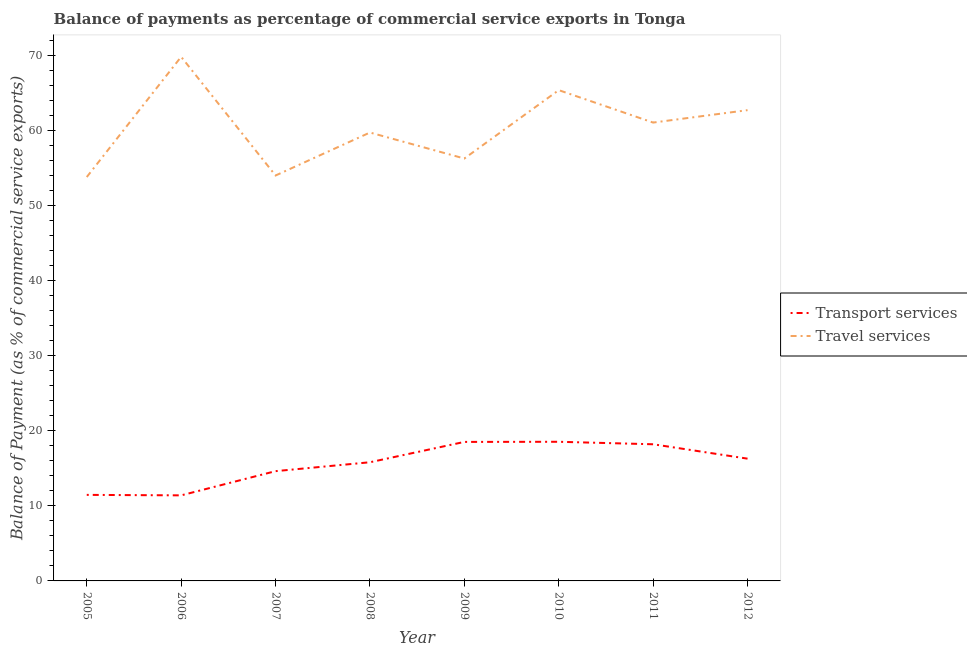Does the line corresponding to balance of payments of transport services intersect with the line corresponding to balance of payments of travel services?
Ensure brevity in your answer.  No. What is the balance of payments of transport services in 2010?
Offer a terse response. 18.55. Across all years, what is the maximum balance of payments of transport services?
Your response must be concise. 18.55. Across all years, what is the minimum balance of payments of transport services?
Keep it short and to the point. 11.41. In which year was the balance of payments of transport services maximum?
Provide a succinct answer. 2010. In which year was the balance of payments of transport services minimum?
Ensure brevity in your answer.  2006. What is the total balance of payments of transport services in the graph?
Offer a terse response. 124.96. What is the difference between the balance of payments of transport services in 2011 and that in 2012?
Provide a succinct answer. 1.92. What is the difference between the balance of payments of travel services in 2007 and the balance of payments of transport services in 2009?
Provide a short and direct response. 35.52. What is the average balance of payments of travel services per year?
Your answer should be very brief. 60.41. In the year 2010, what is the difference between the balance of payments of travel services and balance of payments of transport services?
Your answer should be compact. 46.89. What is the ratio of the balance of payments of transport services in 2006 to that in 2012?
Your response must be concise. 0.7. What is the difference between the highest and the second highest balance of payments of travel services?
Your answer should be compact. 4.45. What is the difference between the highest and the lowest balance of payments of transport services?
Your answer should be very brief. 7.15. In how many years, is the balance of payments of transport services greater than the average balance of payments of transport services taken over all years?
Ensure brevity in your answer.  5. Is the sum of the balance of payments of travel services in 2007 and 2011 greater than the maximum balance of payments of transport services across all years?
Provide a short and direct response. Yes. Is the balance of payments of travel services strictly greater than the balance of payments of transport services over the years?
Ensure brevity in your answer.  Yes. How many lines are there?
Keep it short and to the point. 2. Does the graph contain any zero values?
Offer a very short reply. No. Where does the legend appear in the graph?
Give a very brief answer. Center right. What is the title of the graph?
Offer a very short reply. Balance of payments as percentage of commercial service exports in Tonga. What is the label or title of the Y-axis?
Provide a short and direct response. Balance of Payment (as % of commercial service exports). What is the Balance of Payment (as % of commercial service exports) of Transport services in 2005?
Ensure brevity in your answer.  11.47. What is the Balance of Payment (as % of commercial service exports) of Travel services in 2005?
Your response must be concise. 53.86. What is the Balance of Payment (as % of commercial service exports) in Transport services in 2006?
Provide a short and direct response. 11.41. What is the Balance of Payment (as % of commercial service exports) in Travel services in 2006?
Ensure brevity in your answer.  69.89. What is the Balance of Payment (as % of commercial service exports) of Transport services in 2007?
Provide a succinct answer. 14.64. What is the Balance of Payment (as % of commercial service exports) of Travel services in 2007?
Keep it short and to the point. 54.06. What is the Balance of Payment (as % of commercial service exports) of Transport services in 2008?
Your response must be concise. 15.82. What is the Balance of Payment (as % of commercial service exports) of Travel services in 2008?
Provide a succinct answer. 59.79. What is the Balance of Payment (as % of commercial service exports) of Transport services in 2009?
Offer a terse response. 18.54. What is the Balance of Payment (as % of commercial service exports) in Travel services in 2009?
Offer a very short reply. 56.33. What is the Balance of Payment (as % of commercial service exports) of Transport services in 2010?
Offer a very short reply. 18.55. What is the Balance of Payment (as % of commercial service exports) in Travel services in 2010?
Provide a short and direct response. 65.44. What is the Balance of Payment (as % of commercial service exports) in Transport services in 2011?
Keep it short and to the point. 18.22. What is the Balance of Payment (as % of commercial service exports) of Travel services in 2011?
Offer a terse response. 61.12. What is the Balance of Payment (as % of commercial service exports) of Transport services in 2012?
Your answer should be compact. 16.3. What is the Balance of Payment (as % of commercial service exports) in Travel services in 2012?
Provide a short and direct response. 62.78. Across all years, what is the maximum Balance of Payment (as % of commercial service exports) in Transport services?
Your answer should be compact. 18.55. Across all years, what is the maximum Balance of Payment (as % of commercial service exports) of Travel services?
Keep it short and to the point. 69.89. Across all years, what is the minimum Balance of Payment (as % of commercial service exports) in Transport services?
Your answer should be very brief. 11.41. Across all years, what is the minimum Balance of Payment (as % of commercial service exports) of Travel services?
Provide a succinct answer. 53.86. What is the total Balance of Payment (as % of commercial service exports) in Transport services in the graph?
Your answer should be compact. 124.96. What is the total Balance of Payment (as % of commercial service exports) in Travel services in the graph?
Your answer should be very brief. 483.26. What is the difference between the Balance of Payment (as % of commercial service exports) of Transport services in 2005 and that in 2006?
Provide a succinct answer. 0.06. What is the difference between the Balance of Payment (as % of commercial service exports) in Travel services in 2005 and that in 2006?
Provide a succinct answer. -16.03. What is the difference between the Balance of Payment (as % of commercial service exports) of Transport services in 2005 and that in 2007?
Give a very brief answer. -3.16. What is the difference between the Balance of Payment (as % of commercial service exports) in Travel services in 2005 and that in 2007?
Provide a succinct answer. -0.2. What is the difference between the Balance of Payment (as % of commercial service exports) of Transport services in 2005 and that in 2008?
Offer a terse response. -4.35. What is the difference between the Balance of Payment (as % of commercial service exports) in Travel services in 2005 and that in 2008?
Provide a succinct answer. -5.94. What is the difference between the Balance of Payment (as % of commercial service exports) in Transport services in 2005 and that in 2009?
Offer a terse response. -7.06. What is the difference between the Balance of Payment (as % of commercial service exports) in Travel services in 2005 and that in 2009?
Keep it short and to the point. -2.47. What is the difference between the Balance of Payment (as % of commercial service exports) in Transport services in 2005 and that in 2010?
Ensure brevity in your answer.  -7.08. What is the difference between the Balance of Payment (as % of commercial service exports) in Travel services in 2005 and that in 2010?
Your response must be concise. -11.59. What is the difference between the Balance of Payment (as % of commercial service exports) of Transport services in 2005 and that in 2011?
Ensure brevity in your answer.  -6.75. What is the difference between the Balance of Payment (as % of commercial service exports) of Travel services in 2005 and that in 2011?
Provide a succinct answer. -7.26. What is the difference between the Balance of Payment (as % of commercial service exports) of Transport services in 2005 and that in 2012?
Offer a terse response. -4.83. What is the difference between the Balance of Payment (as % of commercial service exports) in Travel services in 2005 and that in 2012?
Offer a very short reply. -8.92. What is the difference between the Balance of Payment (as % of commercial service exports) of Transport services in 2006 and that in 2007?
Your response must be concise. -3.23. What is the difference between the Balance of Payment (as % of commercial service exports) of Travel services in 2006 and that in 2007?
Your answer should be very brief. 15.83. What is the difference between the Balance of Payment (as % of commercial service exports) in Transport services in 2006 and that in 2008?
Your response must be concise. -4.42. What is the difference between the Balance of Payment (as % of commercial service exports) of Travel services in 2006 and that in 2008?
Your answer should be very brief. 10.1. What is the difference between the Balance of Payment (as % of commercial service exports) in Transport services in 2006 and that in 2009?
Provide a succinct answer. -7.13. What is the difference between the Balance of Payment (as % of commercial service exports) in Travel services in 2006 and that in 2009?
Offer a very short reply. 13.56. What is the difference between the Balance of Payment (as % of commercial service exports) of Transport services in 2006 and that in 2010?
Offer a terse response. -7.15. What is the difference between the Balance of Payment (as % of commercial service exports) in Travel services in 2006 and that in 2010?
Ensure brevity in your answer.  4.45. What is the difference between the Balance of Payment (as % of commercial service exports) of Transport services in 2006 and that in 2011?
Offer a very short reply. -6.81. What is the difference between the Balance of Payment (as % of commercial service exports) in Travel services in 2006 and that in 2011?
Your answer should be compact. 8.77. What is the difference between the Balance of Payment (as % of commercial service exports) in Transport services in 2006 and that in 2012?
Offer a very short reply. -4.89. What is the difference between the Balance of Payment (as % of commercial service exports) of Travel services in 2006 and that in 2012?
Make the answer very short. 7.11. What is the difference between the Balance of Payment (as % of commercial service exports) of Transport services in 2007 and that in 2008?
Give a very brief answer. -1.19. What is the difference between the Balance of Payment (as % of commercial service exports) of Travel services in 2007 and that in 2008?
Make the answer very short. -5.73. What is the difference between the Balance of Payment (as % of commercial service exports) of Transport services in 2007 and that in 2009?
Make the answer very short. -3.9. What is the difference between the Balance of Payment (as % of commercial service exports) in Travel services in 2007 and that in 2009?
Give a very brief answer. -2.27. What is the difference between the Balance of Payment (as % of commercial service exports) of Transport services in 2007 and that in 2010?
Make the answer very short. -3.92. What is the difference between the Balance of Payment (as % of commercial service exports) of Travel services in 2007 and that in 2010?
Provide a succinct answer. -11.38. What is the difference between the Balance of Payment (as % of commercial service exports) in Transport services in 2007 and that in 2011?
Your answer should be compact. -3.58. What is the difference between the Balance of Payment (as % of commercial service exports) in Travel services in 2007 and that in 2011?
Ensure brevity in your answer.  -7.06. What is the difference between the Balance of Payment (as % of commercial service exports) of Transport services in 2007 and that in 2012?
Offer a terse response. -1.67. What is the difference between the Balance of Payment (as % of commercial service exports) of Travel services in 2007 and that in 2012?
Provide a short and direct response. -8.72. What is the difference between the Balance of Payment (as % of commercial service exports) of Transport services in 2008 and that in 2009?
Your answer should be compact. -2.71. What is the difference between the Balance of Payment (as % of commercial service exports) of Travel services in 2008 and that in 2009?
Offer a very short reply. 3.47. What is the difference between the Balance of Payment (as % of commercial service exports) of Transport services in 2008 and that in 2010?
Give a very brief answer. -2.73. What is the difference between the Balance of Payment (as % of commercial service exports) in Travel services in 2008 and that in 2010?
Provide a short and direct response. -5.65. What is the difference between the Balance of Payment (as % of commercial service exports) in Transport services in 2008 and that in 2011?
Offer a very short reply. -2.4. What is the difference between the Balance of Payment (as % of commercial service exports) of Travel services in 2008 and that in 2011?
Provide a short and direct response. -1.33. What is the difference between the Balance of Payment (as % of commercial service exports) of Transport services in 2008 and that in 2012?
Your response must be concise. -0.48. What is the difference between the Balance of Payment (as % of commercial service exports) in Travel services in 2008 and that in 2012?
Your answer should be compact. -2.98. What is the difference between the Balance of Payment (as % of commercial service exports) of Transport services in 2009 and that in 2010?
Your response must be concise. -0.02. What is the difference between the Balance of Payment (as % of commercial service exports) of Travel services in 2009 and that in 2010?
Your response must be concise. -9.12. What is the difference between the Balance of Payment (as % of commercial service exports) in Transport services in 2009 and that in 2011?
Provide a short and direct response. 0.31. What is the difference between the Balance of Payment (as % of commercial service exports) of Travel services in 2009 and that in 2011?
Make the answer very short. -4.79. What is the difference between the Balance of Payment (as % of commercial service exports) of Transport services in 2009 and that in 2012?
Your answer should be very brief. 2.23. What is the difference between the Balance of Payment (as % of commercial service exports) in Travel services in 2009 and that in 2012?
Offer a terse response. -6.45. What is the difference between the Balance of Payment (as % of commercial service exports) in Transport services in 2010 and that in 2011?
Offer a very short reply. 0.33. What is the difference between the Balance of Payment (as % of commercial service exports) in Travel services in 2010 and that in 2011?
Provide a short and direct response. 4.33. What is the difference between the Balance of Payment (as % of commercial service exports) of Transport services in 2010 and that in 2012?
Ensure brevity in your answer.  2.25. What is the difference between the Balance of Payment (as % of commercial service exports) in Travel services in 2010 and that in 2012?
Give a very brief answer. 2.67. What is the difference between the Balance of Payment (as % of commercial service exports) of Transport services in 2011 and that in 2012?
Your answer should be very brief. 1.92. What is the difference between the Balance of Payment (as % of commercial service exports) in Travel services in 2011 and that in 2012?
Provide a short and direct response. -1.66. What is the difference between the Balance of Payment (as % of commercial service exports) of Transport services in 2005 and the Balance of Payment (as % of commercial service exports) of Travel services in 2006?
Ensure brevity in your answer.  -58.42. What is the difference between the Balance of Payment (as % of commercial service exports) in Transport services in 2005 and the Balance of Payment (as % of commercial service exports) in Travel services in 2007?
Your answer should be compact. -42.59. What is the difference between the Balance of Payment (as % of commercial service exports) in Transport services in 2005 and the Balance of Payment (as % of commercial service exports) in Travel services in 2008?
Your answer should be compact. -48.32. What is the difference between the Balance of Payment (as % of commercial service exports) of Transport services in 2005 and the Balance of Payment (as % of commercial service exports) of Travel services in 2009?
Ensure brevity in your answer.  -44.85. What is the difference between the Balance of Payment (as % of commercial service exports) of Transport services in 2005 and the Balance of Payment (as % of commercial service exports) of Travel services in 2010?
Ensure brevity in your answer.  -53.97. What is the difference between the Balance of Payment (as % of commercial service exports) in Transport services in 2005 and the Balance of Payment (as % of commercial service exports) in Travel services in 2011?
Make the answer very short. -49.65. What is the difference between the Balance of Payment (as % of commercial service exports) in Transport services in 2005 and the Balance of Payment (as % of commercial service exports) in Travel services in 2012?
Offer a very short reply. -51.3. What is the difference between the Balance of Payment (as % of commercial service exports) in Transport services in 2006 and the Balance of Payment (as % of commercial service exports) in Travel services in 2007?
Your answer should be compact. -42.65. What is the difference between the Balance of Payment (as % of commercial service exports) of Transport services in 2006 and the Balance of Payment (as % of commercial service exports) of Travel services in 2008?
Provide a short and direct response. -48.38. What is the difference between the Balance of Payment (as % of commercial service exports) in Transport services in 2006 and the Balance of Payment (as % of commercial service exports) in Travel services in 2009?
Provide a short and direct response. -44.92. What is the difference between the Balance of Payment (as % of commercial service exports) in Transport services in 2006 and the Balance of Payment (as % of commercial service exports) in Travel services in 2010?
Provide a short and direct response. -54.04. What is the difference between the Balance of Payment (as % of commercial service exports) in Transport services in 2006 and the Balance of Payment (as % of commercial service exports) in Travel services in 2011?
Offer a very short reply. -49.71. What is the difference between the Balance of Payment (as % of commercial service exports) in Transport services in 2006 and the Balance of Payment (as % of commercial service exports) in Travel services in 2012?
Give a very brief answer. -51.37. What is the difference between the Balance of Payment (as % of commercial service exports) of Transport services in 2007 and the Balance of Payment (as % of commercial service exports) of Travel services in 2008?
Offer a terse response. -45.15. What is the difference between the Balance of Payment (as % of commercial service exports) of Transport services in 2007 and the Balance of Payment (as % of commercial service exports) of Travel services in 2009?
Give a very brief answer. -41.69. What is the difference between the Balance of Payment (as % of commercial service exports) of Transport services in 2007 and the Balance of Payment (as % of commercial service exports) of Travel services in 2010?
Provide a succinct answer. -50.81. What is the difference between the Balance of Payment (as % of commercial service exports) in Transport services in 2007 and the Balance of Payment (as % of commercial service exports) in Travel services in 2011?
Make the answer very short. -46.48. What is the difference between the Balance of Payment (as % of commercial service exports) in Transport services in 2007 and the Balance of Payment (as % of commercial service exports) in Travel services in 2012?
Your answer should be very brief. -48.14. What is the difference between the Balance of Payment (as % of commercial service exports) in Transport services in 2008 and the Balance of Payment (as % of commercial service exports) in Travel services in 2009?
Offer a terse response. -40.5. What is the difference between the Balance of Payment (as % of commercial service exports) in Transport services in 2008 and the Balance of Payment (as % of commercial service exports) in Travel services in 2010?
Your response must be concise. -49.62. What is the difference between the Balance of Payment (as % of commercial service exports) in Transport services in 2008 and the Balance of Payment (as % of commercial service exports) in Travel services in 2011?
Your answer should be very brief. -45.29. What is the difference between the Balance of Payment (as % of commercial service exports) in Transport services in 2008 and the Balance of Payment (as % of commercial service exports) in Travel services in 2012?
Keep it short and to the point. -46.95. What is the difference between the Balance of Payment (as % of commercial service exports) in Transport services in 2009 and the Balance of Payment (as % of commercial service exports) in Travel services in 2010?
Offer a very short reply. -46.91. What is the difference between the Balance of Payment (as % of commercial service exports) of Transport services in 2009 and the Balance of Payment (as % of commercial service exports) of Travel services in 2011?
Keep it short and to the point. -42.58. What is the difference between the Balance of Payment (as % of commercial service exports) in Transport services in 2009 and the Balance of Payment (as % of commercial service exports) in Travel services in 2012?
Provide a succinct answer. -44.24. What is the difference between the Balance of Payment (as % of commercial service exports) in Transport services in 2010 and the Balance of Payment (as % of commercial service exports) in Travel services in 2011?
Ensure brevity in your answer.  -42.56. What is the difference between the Balance of Payment (as % of commercial service exports) of Transport services in 2010 and the Balance of Payment (as % of commercial service exports) of Travel services in 2012?
Your answer should be compact. -44.22. What is the difference between the Balance of Payment (as % of commercial service exports) of Transport services in 2011 and the Balance of Payment (as % of commercial service exports) of Travel services in 2012?
Your answer should be very brief. -44.55. What is the average Balance of Payment (as % of commercial service exports) in Transport services per year?
Provide a succinct answer. 15.62. What is the average Balance of Payment (as % of commercial service exports) in Travel services per year?
Give a very brief answer. 60.41. In the year 2005, what is the difference between the Balance of Payment (as % of commercial service exports) of Transport services and Balance of Payment (as % of commercial service exports) of Travel services?
Ensure brevity in your answer.  -42.38. In the year 2006, what is the difference between the Balance of Payment (as % of commercial service exports) in Transport services and Balance of Payment (as % of commercial service exports) in Travel services?
Your response must be concise. -58.48. In the year 2007, what is the difference between the Balance of Payment (as % of commercial service exports) in Transport services and Balance of Payment (as % of commercial service exports) in Travel services?
Your answer should be very brief. -39.42. In the year 2008, what is the difference between the Balance of Payment (as % of commercial service exports) of Transport services and Balance of Payment (as % of commercial service exports) of Travel services?
Make the answer very short. -43.97. In the year 2009, what is the difference between the Balance of Payment (as % of commercial service exports) of Transport services and Balance of Payment (as % of commercial service exports) of Travel services?
Provide a succinct answer. -37.79. In the year 2010, what is the difference between the Balance of Payment (as % of commercial service exports) in Transport services and Balance of Payment (as % of commercial service exports) in Travel services?
Ensure brevity in your answer.  -46.89. In the year 2011, what is the difference between the Balance of Payment (as % of commercial service exports) of Transport services and Balance of Payment (as % of commercial service exports) of Travel services?
Your answer should be very brief. -42.9. In the year 2012, what is the difference between the Balance of Payment (as % of commercial service exports) of Transport services and Balance of Payment (as % of commercial service exports) of Travel services?
Offer a terse response. -46.47. What is the ratio of the Balance of Payment (as % of commercial service exports) of Travel services in 2005 to that in 2006?
Give a very brief answer. 0.77. What is the ratio of the Balance of Payment (as % of commercial service exports) in Transport services in 2005 to that in 2007?
Keep it short and to the point. 0.78. What is the ratio of the Balance of Payment (as % of commercial service exports) in Travel services in 2005 to that in 2007?
Your answer should be compact. 1. What is the ratio of the Balance of Payment (as % of commercial service exports) in Transport services in 2005 to that in 2008?
Your answer should be very brief. 0.73. What is the ratio of the Balance of Payment (as % of commercial service exports) in Travel services in 2005 to that in 2008?
Your answer should be very brief. 0.9. What is the ratio of the Balance of Payment (as % of commercial service exports) in Transport services in 2005 to that in 2009?
Make the answer very short. 0.62. What is the ratio of the Balance of Payment (as % of commercial service exports) of Travel services in 2005 to that in 2009?
Provide a short and direct response. 0.96. What is the ratio of the Balance of Payment (as % of commercial service exports) in Transport services in 2005 to that in 2010?
Your answer should be very brief. 0.62. What is the ratio of the Balance of Payment (as % of commercial service exports) of Travel services in 2005 to that in 2010?
Provide a short and direct response. 0.82. What is the ratio of the Balance of Payment (as % of commercial service exports) in Transport services in 2005 to that in 2011?
Ensure brevity in your answer.  0.63. What is the ratio of the Balance of Payment (as % of commercial service exports) of Travel services in 2005 to that in 2011?
Offer a very short reply. 0.88. What is the ratio of the Balance of Payment (as % of commercial service exports) of Transport services in 2005 to that in 2012?
Keep it short and to the point. 0.7. What is the ratio of the Balance of Payment (as % of commercial service exports) in Travel services in 2005 to that in 2012?
Give a very brief answer. 0.86. What is the ratio of the Balance of Payment (as % of commercial service exports) of Transport services in 2006 to that in 2007?
Your response must be concise. 0.78. What is the ratio of the Balance of Payment (as % of commercial service exports) in Travel services in 2006 to that in 2007?
Your response must be concise. 1.29. What is the ratio of the Balance of Payment (as % of commercial service exports) in Transport services in 2006 to that in 2008?
Provide a short and direct response. 0.72. What is the ratio of the Balance of Payment (as % of commercial service exports) in Travel services in 2006 to that in 2008?
Offer a terse response. 1.17. What is the ratio of the Balance of Payment (as % of commercial service exports) in Transport services in 2006 to that in 2009?
Your answer should be very brief. 0.62. What is the ratio of the Balance of Payment (as % of commercial service exports) in Travel services in 2006 to that in 2009?
Provide a short and direct response. 1.24. What is the ratio of the Balance of Payment (as % of commercial service exports) of Transport services in 2006 to that in 2010?
Provide a succinct answer. 0.61. What is the ratio of the Balance of Payment (as % of commercial service exports) of Travel services in 2006 to that in 2010?
Make the answer very short. 1.07. What is the ratio of the Balance of Payment (as % of commercial service exports) of Transport services in 2006 to that in 2011?
Provide a succinct answer. 0.63. What is the ratio of the Balance of Payment (as % of commercial service exports) in Travel services in 2006 to that in 2011?
Offer a very short reply. 1.14. What is the ratio of the Balance of Payment (as % of commercial service exports) of Transport services in 2006 to that in 2012?
Provide a short and direct response. 0.7. What is the ratio of the Balance of Payment (as % of commercial service exports) of Travel services in 2006 to that in 2012?
Give a very brief answer. 1.11. What is the ratio of the Balance of Payment (as % of commercial service exports) in Transport services in 2007 to that in 2008?
Provide a succinct answer. 0.93. What is the ratio of the Balance of Payment (as % of commercial service exports) of Travel services in 2007 to that in 2008?
Offer a very short reply. 0.9. What is the ratio of the Balance of Payment (as % of commercial service exports) of Transport services in 2007 to that in 2009?
Your answer should be very brief. 0.79. What is the ratio of the Balance of Payment (as % of commercial service exports) of Travel services in 2007 to that in 2009?
Your response must be concise. 0.96. What is the ratio of the Balance of Payment (as % of commercial service exports) in Transport services in 2007 to that in 2010?
Keep it short and to the point. 0.79. What is the ratio of the Balance of Payment (as % of commercial service exports) in Travel services in 2007 to that in 2010?
Provide a short and direct response. 0.83. What is the ratio of the Balance of Payment (as % of commercial service exports) of Transport services in 2007 to that in 2011?
Provide a succinct answer. 0.8. What is the ratio of the Balance of Payment (as % of commercial service exports) in Travel services in 2007 to that in 2011?
Give a very brief answer. 0.88. What is the ratio of the Balance of Payment (as % of commercial service exports) in Transport services in 2007 to that in 2012?
Give a very brief answer. 0.9. What is the ratio of the Balance of Payment (as % of commercial service exports) of Travel services in 2007 to that in 2012?
Offer a very short reply. 0.86. What is the ratio of the Balance of Payment (as % of commercial service exports) in Transport services in 2008 to that in 2009?
Your answer should be compact. 0.85. What is the ratio of the Balance of Payment (as % of commercial service exports) in Travel services in 2008 to that in 2009?
Give a very brief answer. 1.06. What is the ratio of the Balance of Payment (as % of commercial service exports) of Transport services in 2008 to that in 2010?
Ensure brevity in your answer.  0.85. What is the ratio of the Balance of Payment (as % of commercial service exports) in Travel services in 2008 to that in 2010?
Provide a short and direct response. 0.91. What is the ratio of the Balance of Payment (as % of commercial service exports) in Transport services in 2008 to that in 2011?
Your response must be concise. 0.87. What is the ratio of the Balance of Payment (as % of commercial service exports) in Travel services in 2008 to that in 2011?
Make the answer very short. 0.98. What is the ratio of the Balance of Payment (as % of commercial service exports) of Transport services in 2008 to that in 2012?
Keep it short and to the point. 0.97. What is the ratio of the Balance of Payment (as % of commercial service exports) in Travel services in 2008 to that in 2012?
Ensure brevity in your answer.  0.95. What is the ratio of the Balance of Payment (as % of commercial service exports) in Travel services in 2009 to that in 2010?
Your response must be concise. 0.86. What is the ratio of the Balance of Payment (as % of commercial service exports) of Transport services in 2009 to that in 2011?
Provide a succinct answer. 1.02. What is the ratio of the Balance of Payment (as % of commercial service exports) in Travel services in 2009 to that in 2011?
Your answer should be very brief. 0.92. What is the ratio of the Balance of Payment (as % of commercial service exports) in Transport services in 2009 to that in 2012?
Give a very brief answer. 1.14. What is the ratio of the Balance of Payment (as % of commercial service exports) of Travel services in 2009 to that in 2012?
Your response must be concise. 0.9. What is the ratio of the Balance of Payment (as % of commercial service exports) of Transport services in 2010 to that in 2011?
Provide a short and direct response. 1.02. What is the ratio of the Balance of Payment (as % of commercial service exports) of Travel services in 2010 to that in 2011?
Provide a succinct answer. 1.07. What is the ratio of the Balance of Payment (as % of commercial service exports) of Transport services in 2010 to that in 2012?
Ensure brevity in your answer.  1.14. What is the ratio of the Balance of Payment (as % of commercial service exports) in Travel services in 2010 to that in 2012?
Keep it short and to the point. 1.04. What is the ratio of the Balance of Payment (as % of commercial service exports) of Transport services in 2011 to that in 2012?
Your answer should be compact. 1.12. What is the ratio of the Balance of Payment (as % of commercial service exports) in Travel services in 2011 to that in 2012?
Offer a very short reply. 0.97. What is the difference between the highest and the second highest Balance of Payment (as % of commercial service exports) of Transport services?
Give a very brief answer. 0.02. What is the difference between the highest and the second highest Balance of Payment (as % of commercial service exports) of Travel services?
Your answer should be very brief. 4.45. What is the difference between the highest and the lowest Balance of Payment (as % of commercial service exports) of Transport services?
Your answer should be very brief. 7.15. What is the difference between the highest and the lowest Balance of Payment (as % of commercial service exports) in Travel services?
Your response must be concise. 16.03. 